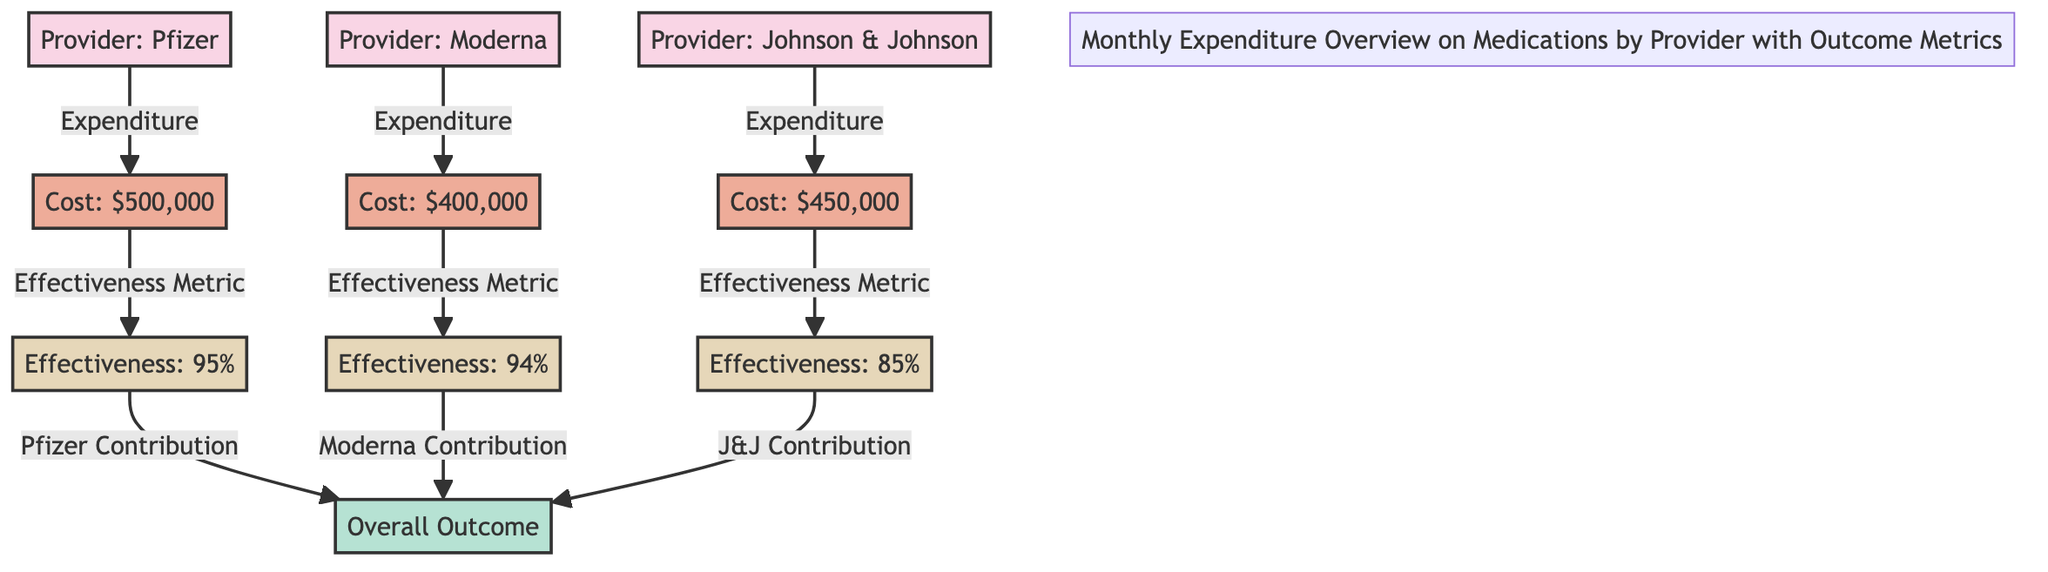What is the expenditure for Pfizer? The diagram connects the node for Pfizer to its expenditure node, which clearly states the cost associated with this provider. The specific value for Pfizer's cost is $500,000.
Answer: $500,000 What is the effectiveness percentage for Moderna? The diagram indicates the effectiveness metric for Moderna, which is referenced directly under the cost node for this provider. The effectiveness percentage provided for Moderna is 94%.
Answer: 94% Which provider has the highest expenditure? By comparing the costs of the providers listed in the diagram, it is evident that Pfizer has the highest expenditure at $500,000 compared to Moderna's $400,000 and Johnson & Johnson's $450,000.
Answer: Pfizer What is the overall outcome influenced by Johnson & Johnson? The diagram shows that effectiveness from each provider contributes to the overall outcome. The effectiveness for Johnson & Johnson is 85%, which directly influences the overall outcome, but the question focuses on the provider's contribution, which is represented as "J&J Contribution."
Answer: J&J Contribution How many providers are represented in this diagram? The diagram explicitly lists three providers: Pfizer, Moderna, and Johnson & Johnson. These nodes can be counted directly, and thus the total number of providers can be identified.
Answer: 3 Which provider has the lowest effectiveness percentage? By examining the effectiveness percentages connected to each provider in the diagram, it is clear that Johnson & Johnson has the lowest effectiveness at 85%, as compared to 94% for Moderna and 95% for Pfizer.
Answer: Johnson & Johnson What is the total cost of medications for all providers combined? The total cost can be found by adding the expenditures for each provider: $500,000 (Pfizer) + $400,000 (Moderna) + $450,000 (Johnson & Johnson) which totals to $1,350,000.
Answer: $1,350,000 Which color represents the provider nodes in the diagram? The diagram uses a specific color scheme to categorize its components. The provider nodes are styled in pink, which can be identified by examining the color assigned within the diagram's class definitions.
Answer: Pink What metric is shown beside the expenditure for each provider? Each expenditure node is directly connected to an effectiveness metric node, indicating that the effectiveness of the medication is measured alongside the cost for each provider.
Answer: Effectiveness Metric 